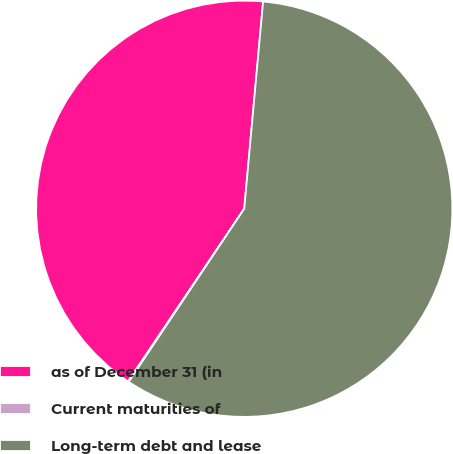<chart> <loc_0><loc_0><loc_500><loc_500><pie_chart><fcel>as of December 31 (in<fcel>Current maturities of<fcel>Long-term debt and lease<nl><fcel>42.02%<fcel>0.06%<fcel>57.92%<nl></chart> 